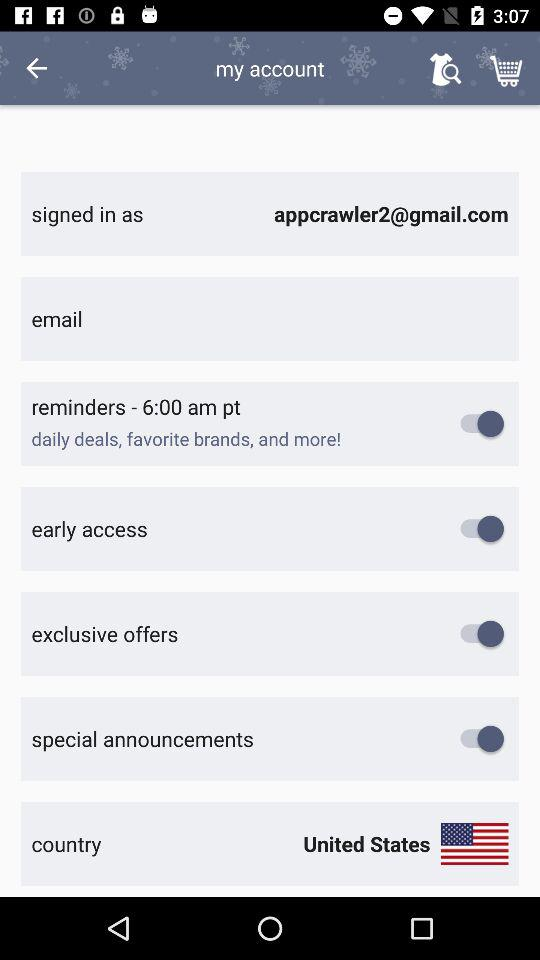What is the status of "early access"? The status is "on". 